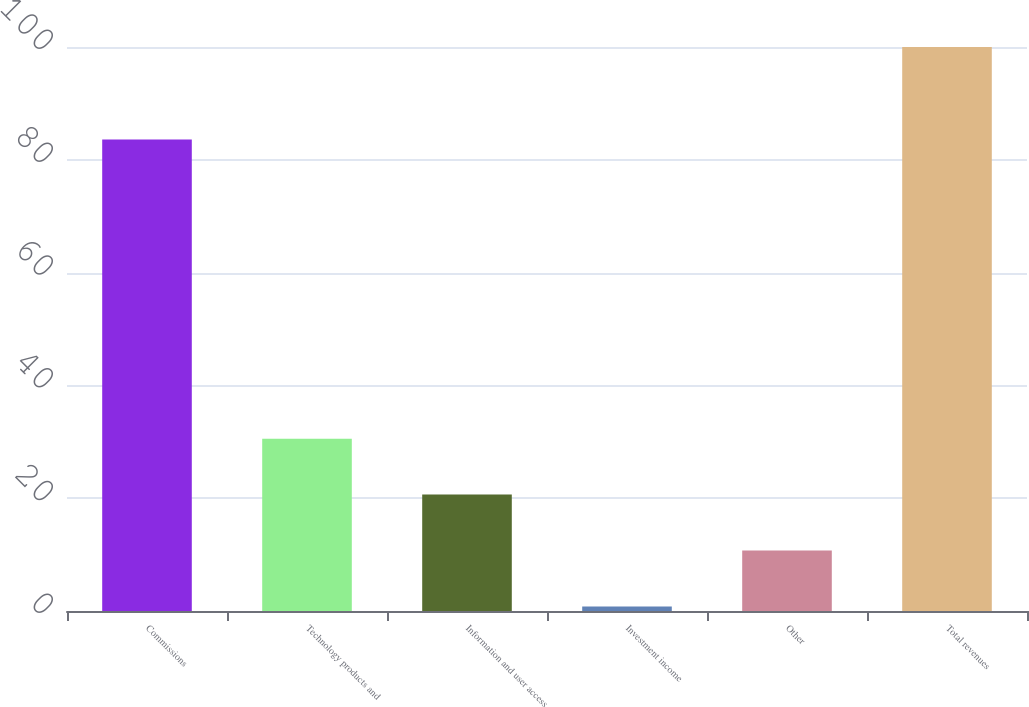Convert chart to OTSL. <chart><loc_0><loc_0><loc_500><loc_500><bar_chart><fcel>Commissions<fcel>Technology products and<fcel>Information and user access<fcel>Investment income<fcel>Other<fcel>Total revenues<nl><fcel>83.6<fcel>30.56<fcel>20.64<fcel>0.8<fcel>10.72<fcel>100<nl></chart> 